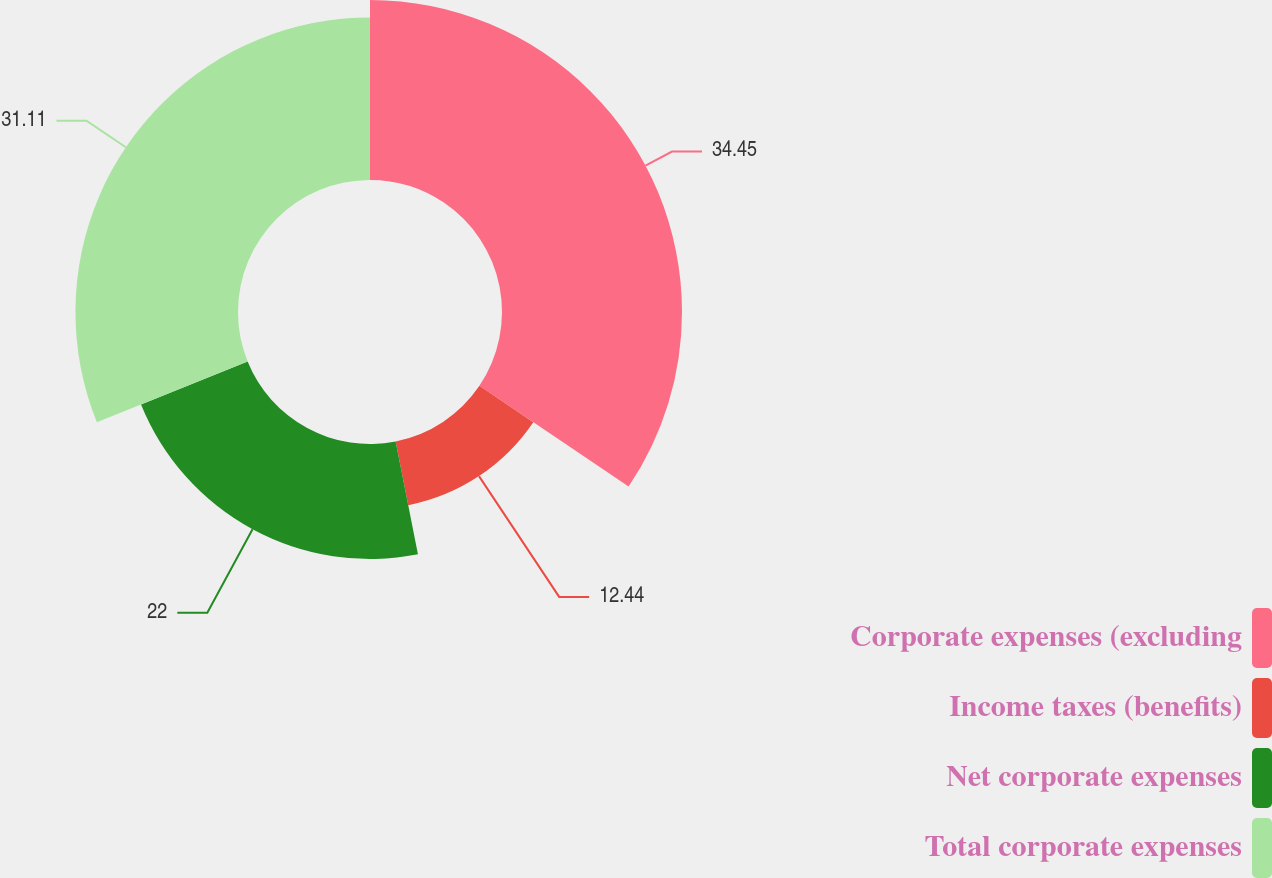Convert chart to OTSL. <chart><loc_0><loc_0><loc_500><loc_500><pie_chart><fcel>Corporate expenses (excluding<fcel>Income taxes (benefits)<fcel>Net corporate expenses<fcel>Total corporate expenses<nl><fcel>34.45%<fcel>12.44%<fcel>22.0%<fcel>31.11%<nl></chart> 